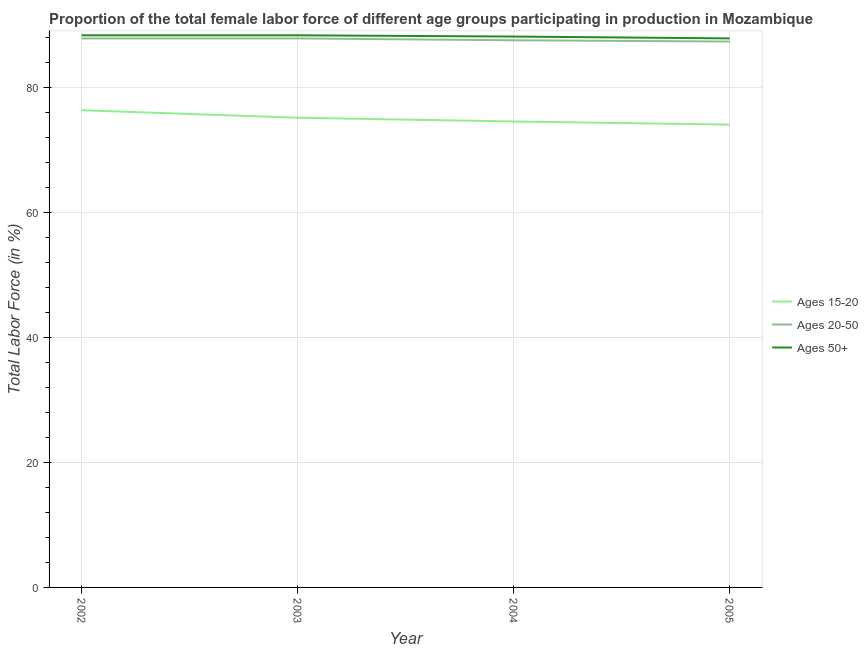Is the number of lines equal to the number of legend labels?
Your answer should be very brief. Yes. What is the percentage of female labor force within the age group 15-20 in 2003?
Provide a succinct answer. 75.2. Across all years, what is the maximum percentage of female labor force within the age group 15-20?
Your answer should be very brief. 76.4. Across all years, what is the minimum percentage of female labor force above age 50?
Your response must be concise. 87.9. What is the total percentage of female labor force within the age group 20-50 in the graph?
Your answer should be very brief. 350.8. What is the difference between the percentage of female labor force above age 50 in 2003 and that in 2004?
Keep it short and to the point. 0.2. What is the difference between the percentage of female labor force within the age group 15-20 in 2005 and the percentage of female labor force above age 50 in 2002?
Keep it short and to the point. -14.3. What is the average percentage of female labor force above age 50 per year?
Ensure brevity in your answer.  88.23. In how many years, is the percentage of female labor force above age 50 greater than 20 %?
Offer a terse response. 4. What is the ratio of the percentage of female labor force within the age group 20-50 in 2003 to that in 2004?
Offer a terse response. 1. Is the percentage of female labor force above age 50 in 2002 less than that in 2005?
Provide a succinct answer. No. Is the difference between the percentage of female labor force within the age group 20-50 in 2004 and 2005 greater than the difference between the percentage of female labor force within the age group 15-20 in 2004 and 2005?
Provide a succinct answer. No. What is the difference between the highest and the second highest percentage of female labor force within the age group 20-50?
Offer a very short reply. 0. Is the sum of the percentage of female labor force within the age group 20-50 in 2003 and 2004 greater than the maximum percentage of female labor force above age 50 across all years?
Your response must be concise. Yes. Is it the case that in every year, the sum of the percentage of female labor force within the age group 15-20 and percentage of female labor force within the age group 20-50 is greater than the percentage of female labor force above age 50?
Offer a terse response. Yes. Does the percentage of female labor force within the age group 15-20 monotonically increase over the years?
Your answer should be very brief. No. Is the percentage of female labor force above age 50 strictly greater than the percentage of female labor force within the age group 20-50 over the years?
Make the answer very short. Yes. Is the percentage of female labor force above age 50 strictly less than the percentage of female labor force within the age group 20-50 over the years?
Make the answer very short. No. How many lines are there?
Make the answer very short. 3. Does the graph contain grids?
Your response must be concise. Yes. How many legend labels are there?
Give a very brief answer. 3. How are the legend labels stacked?
Offer a terse response. Vertical. What is the title of the graph?
Provide a short and direct response. Proportion of the total female labor force of different age groups participating in production in Mozambique. What is the label or title of the Y-axis?
Provide a succinct answer. Total Labor Force (in %). What is the Total Labor Force (in %) of Ages 15-20 in 2002?
Your answer should be compact. 76.4. What is the Total Labor Force (in %) of Ages 20-50 in 2002?
Ensure brevity in your answer.  87.9. What is the Total Labor Force (in %) of Ages 50+ in 2002?
Make the answer very short. 88.4. What is the Total Labor Force (in %) of Ages 15-20 in 2003?
Your answer should be compact. 75.2. What is the Total Labor Force (in %) of Ages 20-50 in 2003?
Offer a terse response. 87.9. What is the Total Labor Force (in %) in Ages 50+ in 2003?
Make the answer very short. 88.4. What is the Total Labor Force (in %) in Ages 15-20 in 2004?
Your response must be concise. 74.6. What is the Total Labor Force (in %) in Ages 20-50 in 2004?
Offer a very short reply. 87.6. What is the Total Labor Force (in %) of Ages 50+ in 2004?
Make the answer very short. 88.2. What is the Total Labor Force (in %) of Ages 15-20 in 2005?
Keep it short and to the point. 74.1. What is the Total Labor Force (in %) in Ages 20-50 in 2005?
Your answer should be compact. 87.4. What is the Total Labor Force (in %) of Ages 50+ in 2005?
Your answer should be compact. 87.9. Across all years, what is the maximum Total Labor Force (in %) in Ages 15-20?
Ensure brevity in your answer.  76.4. Across all years, what is the maximum Total Labor Force (in %) of Ages 20-50?
Provide a short and direct response. 87.9. Across all years, what is the maximum Total Labor Force (in %) in Ages 50+?
Your answer should be compact. 88.4. Across all years, what is the minimum Total Labor Force (in %) in Ages 15-20?
Offer a very short reply. 74.1. Across all years, what is the minimum Total Labor Force (in %) in Ages 20-50?
Provide a succinct answer. 87.4. Across all years, what is the minimum Total Labor Force (in %) in Ages 50+?
Provide a succinct answer. 87.9. What is the total Total Labor Force (in %) in Ages 15-20 in the graph?
Give a very brief answer. 300.3. What is the total Total Labor Force (in %) in Ages 20-50 in the graph?
Give a very brief answer. 350.8. What is the total Total Labor Force (in %) of Ages 50+ in the graph?
Offer a terse response. 352.9. What is the difference between the Total Labor Force (in %) in Ages 20-50 in 2002 and that in 2004?
Offer a very short reply. 0.3. What is the difference between the Total Labor Force (in %) of Ages 20-50 in 2002 and that in 2005?
Provide a succinct answer. 0.5. What is the difference between the Total Labor Force (in %) of Ages 20-50 in 2003 and that in 2004?
Give a very brief answer. 0.3. What is the difference between the Total Labor Force (in %) of Ages 20-50 in 2003 and that in 2005?
Offer a very short reply. 0.5. What is the difference between the Total Labor Force (in %) in Ages 50+ in 2003 and that in 2005?
Your answer should be very brief. 0.5. What is the difference between the Total Labor Force (in %) of Ages 15-20 in 2004 and that in 2005?
Give a very brief answer. 0.5. What is the difference between the Total Labor Force (in %) in Ages 20-50 in 2004 and that in 2005?
Your response must be concise. 0.2. What is the difference between the Total Labor Force (in %) of Ages 15-20 in 2002 and the Total Labor Force (in %) of Ages 20-50 in 2003?
Keep it short and to the point. -11.5. What is the difference between the Total Labor Force (in %) of Ages 15-20 in 2002 and the Total Labor Force (in %) of Ages 50+ in 2003?
Offer a very short reply. -12. What is the difference between the Total Labor Force (in %) in Ages 20-50 in 2002 and the Total Labor Force (in %) in Ages 50+ in 2003?
Provide a short and direct response. -0.5. What is the difference between the Total Labor Force (in %) in Ages 20-50 in 2002 and the Total Labor Force (in %) in Ages 50+ in 2004?
Keep it short and to the point. -0.3. What is the difference between the Total Labor Force (in %) of Ages 15-20 in 2002 and the Total Labor Force (in %) of Ages 20-50 in 2005?
Ensure brevity in your answer.  -11. What is the difference between the Total Labor Force (in %) of Ages 15-20 in 2002 and the Total Labor Force (in %) of Ages 50+ in 2005?
Your answer should be very brief. -11.5. What is the difference between the Total Labor Force (in %) in Ages 15-20 in 2003 and the Total Labor Force (in %) in Ages 20-50 in 2005?
Your response must be concise. -12.2. What is the difference between the Total Labor Force (in %) of Ages 15-20 in 2003 and the Total Labor Force (in %) of Ages 50+ in 2005?
Your answer should be very brief. -12.7. What is the difference between the Total Labor Force (in %) of Ages 20-50 in 2003 and the Total Labor Force (in %) of Ages 50+ in 2005?
Provide a short and direct response. 0. What is the difference between the Total Labor Force (in %) of Ages 15-20 in 2004 and the Total Labor Force (in %) of Ages 20-50 in 2005?
Ensure brevity in your answer.  -12.8. What is the difference between the Total Labor Force (in %) in Ages 20-50 in 2004 and the Total Labor Force (in %) in Ages 50+ in 2005?
Provide a succinct answer. -0.3. What is the average Total Labor Force (in %) of Ages 15-20 per year?
Make the answer very short. 75.08. What is the average Total Labor Force (in %) of Ages 20-50 per year?
Your answer should be very brief. 87.7. What is the average Total Labor Force (in %) of Ages 50+ per year?
Your answer should be compact. 88.22. In the year 2002, what is the difference between the Total Labor Force (in %) in Ages 15-20 and Total Labor Force (in %) in Ages 20-50?
Provide a short and direct response. -11.5. In the year 2002, what is the difference between the Total Labor Force (in %) of Ages 15-20 and Total Labor Force (in %) of Ages 50+?
Keep it short and to the point. -12. In the year 2003, what is the difference between the Total Labor Force (in %) in Ages 20-50 and Total Labor Force (in %) in Ages 50+?
Ensure brevity in your answer.  -0.5. In the year 2004, what is the difference between the Total Labor Force (in %) of Ages 15-20 and Total Labor Force (in %) of Ages 20-50?
Offer a very short reply. -13. In the year 2004, what is the difference between the Total Labor Force (in %) in Ages 20-50 and Total Labor Force (in %) in Ages 50+?
Offer a very short reply. -0.6. In the year 2005, what is the difference between the Total Labor Force (in %) in Ages 20-50 and Total Labor Force (in %) in Ages 50+?
Offer a very short reply. -0.5. What is the ratio of the Total Labor Force (in %) in Ages 15-20 in 2002 to that in 2003?
Make the answer very short. 1.02. What is the ratio of the Total Labor Force (in %) of Ages 50+ in 2002 to that in 2003?
Your answer should be compact. 1. What is the ratio of the Total Labor Force (in %) in Ages 15-20 in 2002 to that in 2004?
Make the answer very short. 1.02. What is the ratio of the Total Labor Force (in %) in Ages 20-50 in 2002 to that in 2004?
Make the answer very short. 1. What is the ratio of the Total Labor Force (in %) of Ages 15-20 in 2002 to that in 2005?
Keep it short and to the point. 1.03. What is the ratio of the Total Labor Force (in %) of Ages 50+ in 2002 to that in 2005?
Give a very brief answer. 1.01. What is the ratio of the Total Labor Force (in %) of Ages 15-20 in 2003 to that in 2004?
Your answer should be very brief. 1.01. What is the ratio of the Total Labor Force (in %) of Ages 50+ in 2003 to that in 2004?
Ensure brevity in your answer.  1. What is the ratio of the Total Labor Force (in %) of Ages 15-20 in 2003 to that in 2005?
Make the answer very short. 1.01. What is the ratio of the Total Labor Force (in %) of Ages 15-20 in 2004 to that in 2005?
Make the answer very short. 1.01. What is the ratio of the Total Labor Force (in %) of Ages 50+ in 2004 to that in 2005?
Your answer should be very brief. 1. What is the difference between the highest and the second highest Total Labor Force (in %) of Ages 15-20?
Your answer should be compact. 1.2. What is the difference between the highest and the lowest Total Labor Force (in %) in Ages 15-20?
Keep it short and to the point. 2.3. What is the difference between the highest and the lowest Total Labor Force (in %) in Ages 20-50?
Your answer should be very brief. 0.5. What is the difference between the highest and the lowest Total Labor Force (in %) of Ages 50+?
Provide a succinct answer. 0.5. 